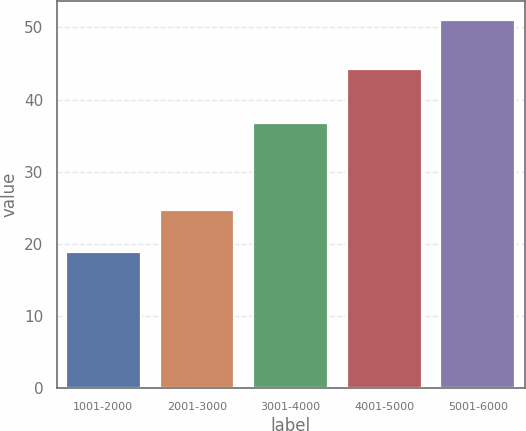Convert chart. <chart><loc_0><loc_0><loc_500><loc_500><bar_chart><fcel>1001-2000<fcel>2001-3000<fcel>3001-4000<fcel>4001-5000<fcel>5001-6000<nl><fcel>18.86<fcel>24.77<fcel>36.8<fcel>44.27<fcel>51.08<nl></chart> 